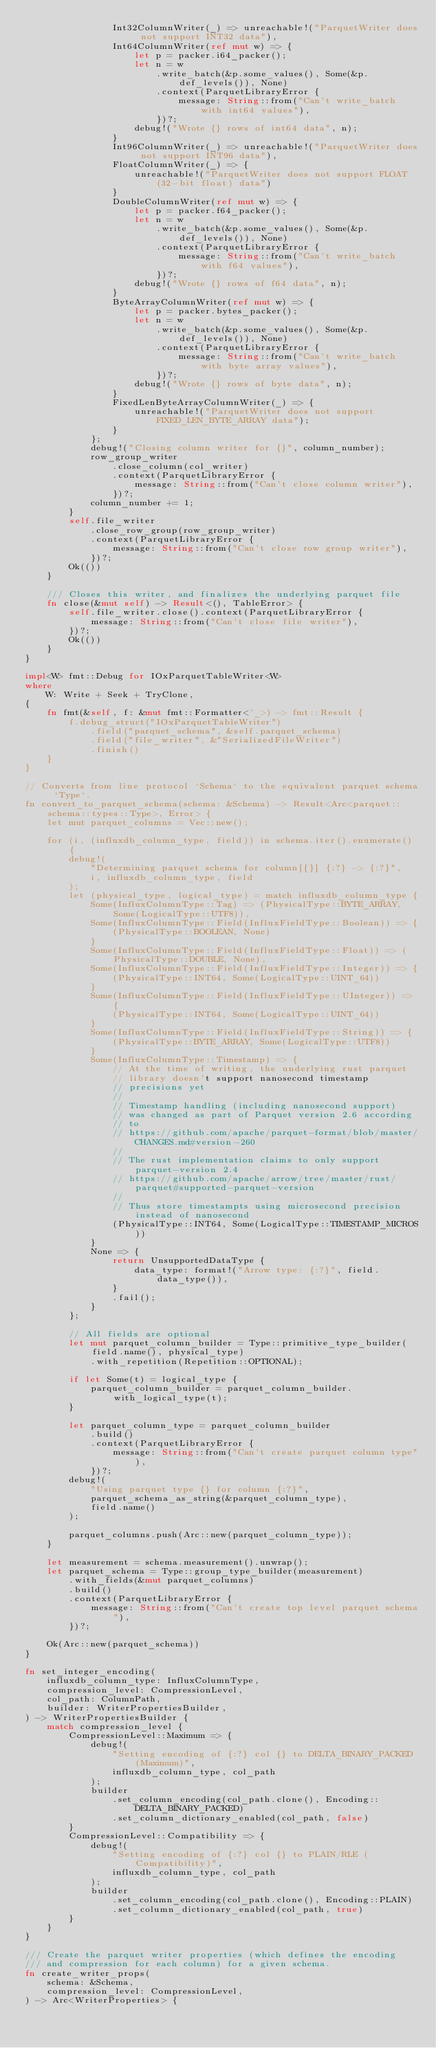Convert code to text. <code><loc_0><loc_0><loc_500><loc_500><_Rust_>                Int32ColumnWriter(_) => unreachable!("ParquetWriter does not support INT32 data"),
                Int64ColumnWriter(ref mut w) => {
                    let p = packer.i64_packer();
                    let n = w
                        .write_batch(&p.some_values(), Some(&p.def_levels()), None)
                        .context(ParquetLibraryError {
                            message: String::from("Can't write_batch with int64 values"),
                        })?;
                    debug!("Wrote {} rows of int64 data", n);
                }
                Int96ColumnWriter(_) => unreachable!("ParquetWriter does not support INT96 data"),
                FloatColumnWriter(_) => {
                    unreachable!("ParquetWriter does not support FLOAT (32-bit float) data")
                }
                DoubleColumnWriter(ref mut w) => {
                    let p = packer.f64_packer();
                    let n = w
                        .write_batch(&p.some_values(), Some(&p.def_levels()), None)
                        .context(ParquetLibraryError {
                            message: String::from("Can't write_batch with f64 values"),
                        })?;
                    debug!("Wrote {} rows of f64 data", n);
                }
                ByteArrayColumnWriter(ref mut w) => {
                    let p = packer.bytes_packer();
                    let n = w
                        .write_batch(&p.some_values(), Some(&p.def_levels()), None)
                        .context(ParquetLibraryError {
                            message: String::from("Can't write_batch with byte array values"),
                        })?;
                    debug!("Wrote {} rows of byte data", n);
                }
                FixedLenByteArrayColumnWriter(_) => {
                    unreachable!("ParquetWriter does not support FIXED_LEN_BYTE_ARRAY data");
                }
            };
            debug!("Closing column writer for {}", column_number);
            row_group_writer
                .close_column(col_writer)
                .context(ParquetLibraryError {
                    message: String::from("Can't close column writer"),
                })?;
            column_number += 1;
        }
        self.file_writer
            .close_row_group(row_group_writer)
            .context(ParquetLibraryError {
                message: String::from("Can't close row group writer"),
            })?;
        Ok(())
    }

    /// Closes this writer, and finalizes the underlying parquet file
    fn close(&mut self) -> Result<(), TableError> {
        self.file_writer.close().context(ParquetLibraryError {
            message: String::from("Can't close file writer"),
        })?;
        Ok(())
    }
}

impl<W> fmt::Debug for IOxParquetTableWriter<W>
where
    W: Write + Seek + TryClone,
{
    fn fmt(&self, f: &mut fmt::Formatter<'_>) -> fmt::Result {
        f.debug_struct("IOxParquetTableWriter")
            .field("parquet_schema", &self.parquet_schema)
            .field("file_writer", &"SerializedFileWriter")
            .finish()
    }
}

// Converts from line protocol `Schema` to the equivalent parquet schema `Type`.
fn convert_to_parquet_schema(schema: &Schema) -> Result<Arc<parquet::schema::types::Type>, Error> {
    let mut parquet_columns = Vec::new();

    for (i, (influxdb_column_type, field)) in schema.iter().enumerate() {
        debug!(
            "Determining parquet schema for column[{}] {:?} -> {:?}",
            i, influxdb_column_type, field
        );
        let (physical_type, logical_type) = match influxdb_column_type {
            Some(InfluxColumnType::Tag) => (PhysicalType::BYTE_ARRAY, Some(LogicalType::UTF8)),
            Some(InfluxColumnType::Field(InfluxFieldType::Boolean)) => {
                (PhysicalType::BOOLEAN, None)
            }
            Some(InfluxColumnType::Field(InfluxFieldType::Float)) => (PhysicalType::DOUBLE, None),
            Some(InfluxColumnType::Field(InfluxFieldType::Integer)) => {
                (PhysicalType::INT64, Some(LogicalType::UINT_64))
            }
            Some(InfluxColumnType::Field(InfluxFieldType::UInteger)) => {
                (PhysicalType::INT64, Some(LogicalType::UINT_64))
            }
            Some(InfluxColumnType::Field(InfluxFieldType::String)) => {
                (PhysicalType::BYTE_ARRAY, Some(LogicalType::UTF8))
            }
            Some(InfluxColumnType::Timestamp) => {
                // At the time of writing, the underlying rust parquet
                // library doesn't support nanosecond timestamp
                // precisions yet
                //
                // Timestamp handling (including nanosecond support)
                // was changed as part of Parquet version 2.6 according
                // to
                // https://github.com/apache/parquet-format/blob/master/CHANGES.md#version-260
                //
                // The rust implementation claims to only support parquet-version 2.4
                // https://github.com/apache/arrow/tree/master/rust/parquet#supported-parquet-version
                //
                // Thus store timestampts using microsecond precision instead of nanosecond
                (PhysicalType::INT64, Some(LogicalType::TIMESTAMP_MICROS))
            }
            None => {
                return UnsupportedDataType {
                    data_type: format!("Arrow type: {:?}", field.data_type()),
                }
                .fail();
            }
        };

        // All fields are optional
        let mut parquet_column_builder = Type::primitive_type_builder(field.name(), physical_type)
            .with_repetition(Repetition::OPTIONAL);

        if let Some(t) = logical_type {
            parquet_column_builder = parquet_column_builder.with_logical_type(t);
        }

        let parquet_column_type = parquet_column_builder
            .build()
            .context(ParquetLibraryError {
                message: String::from("Can't create parquet column type"),
            })?;
        debug!(
            "Using parquet type {} for column {:?}",
            parquet_schema_as_string(&parquet_column_type),
            field.name()
        );

        parquet_columns.push(Arc::new(parquet_column_type));
    }

    let measurement = schema.measurement().unwrap();
    let parquet_schema = Type::group_type_builder(measurement)
        .with_fields(&mut parquet_columns)
        .build()
        .context(ParquetLibraryError {
            message: String::from("Can't create top level parquet schema"),
        })?;

    Ok(Arc::new(parquet_schema))
}

fn set_integer_encoding(
    influxdb_column_type: InfluxColumnType,
    compression_level: CompressionLevel,
    col_path: ColumnPath,
    builder: WriterPropertiesBuilder,
) -> WriterPropertiesBuilder {
    match compression_level {
        CompressionLevel::Maximum => {
            debug!(
                "Setting encoding of {:?} col {} to DELTA_BINARY_PACKED (Maximum)",
                influxdb_column_type, col_path
            );
            builder
                .set_column_encoding(col_path.clone(), Encoding::DELTA_BINARY_PACKED)
                .set_column_dictionary_enabled(col_path, false)
        }
        CompressionLevel::Compatibility => {
            debug!(
                "Setting encoding of {:?} col {} to PLAIN/RLE (Compatibility)",
                influxdb_column_type, col_path
            );
            builder
                .set_column_encoding(col_path.clone(), Encoding::PLAIN)
                .set_column_dictionary_enabled(col_path, true)
        }
    }
}

/// Create the parquet writer properties (which defines the encoding
/// and compression for each column) for a given schema.
fn create_writer_props(
    schema: &Schema,
    compression_level: CompressionLevel,
) -> Arc<WriterProperties> {</code> 